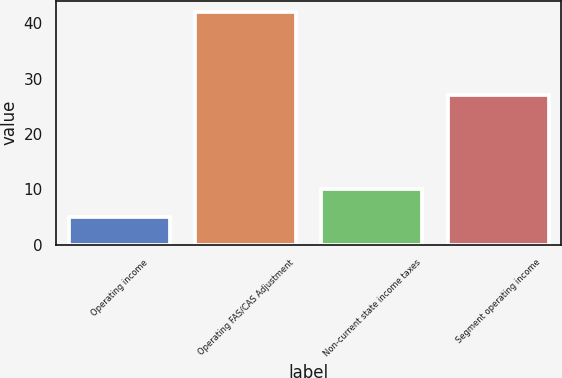Convert chart to OTSL. <chart><loc_0><loc_0><loc_500><loc_500><bar_chart><fcel>Operating income<fcel>Operating FAS/CAS Adjustment<fcel>Non-current state income taxes<fcel>Segment operating income<nl><fcel>5<fcel>42<fcel>10<fcel>27<nl></chart> 